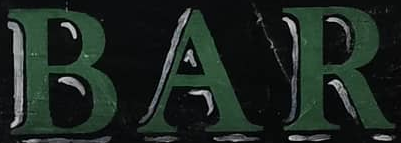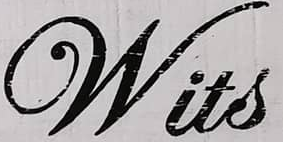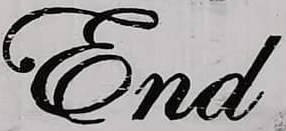What text appears in these images from left to right, separated by a semicolon? BAR; Wits; End 